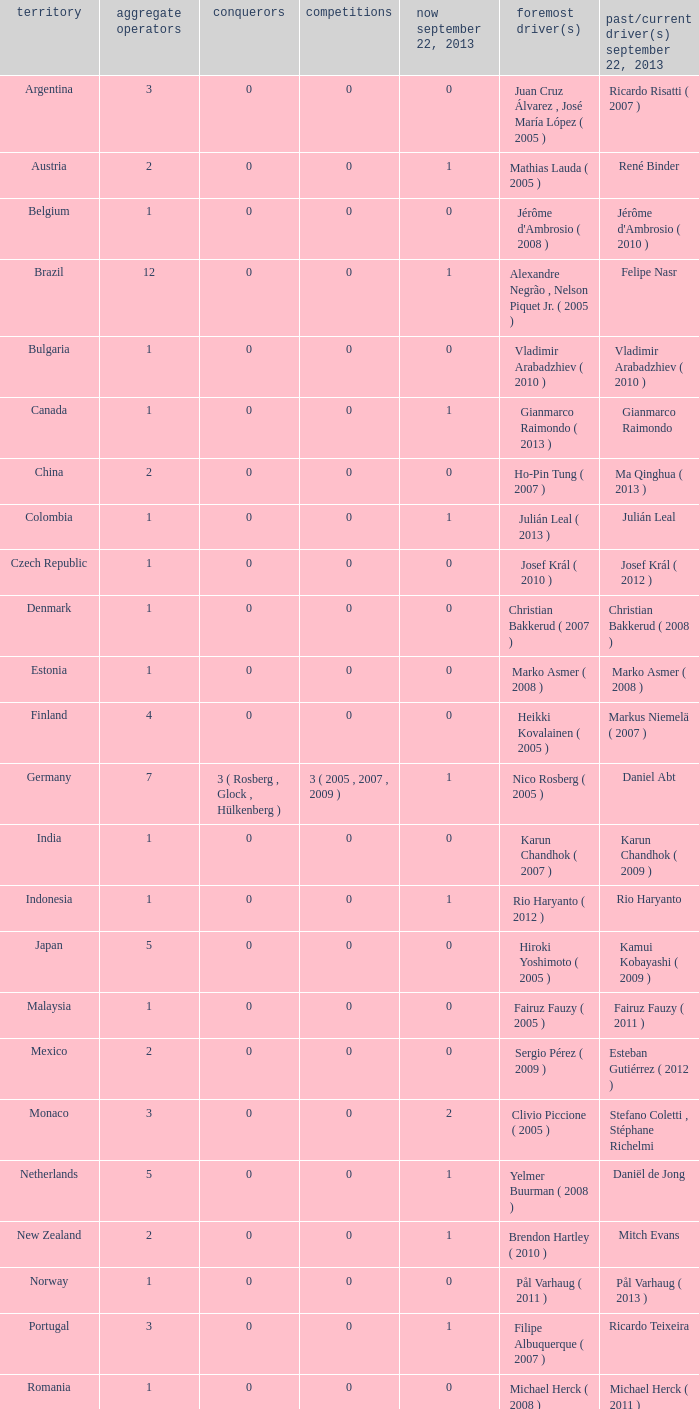How many champions were there when the last driver was Gianmarco Raimondo? 0.0. 